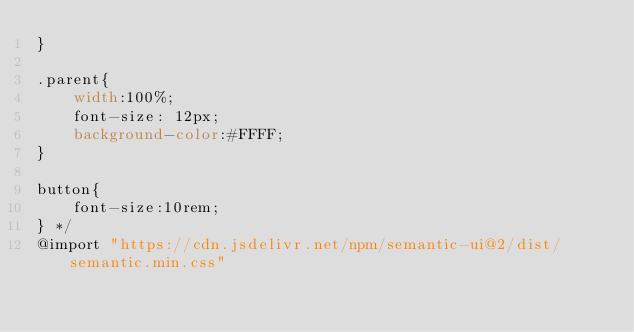Convert code to text. <code><loc_0><loc_0><loc_500><loc_500><_CSS_>}

.parent{
    width:100%;
    font-size: 12px;
    background-color:#FFFF;
}

button{
    font-size:10rem;
} */
@import "https://cdn.jsdelivr.net/npm/semantic-ui@2/dist/semantic.min.css"</code> 